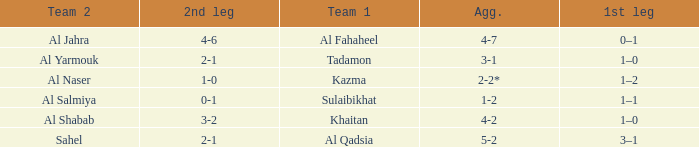What is the 1st leg of the match with a 2nd leg of 3-2? 1–0. 